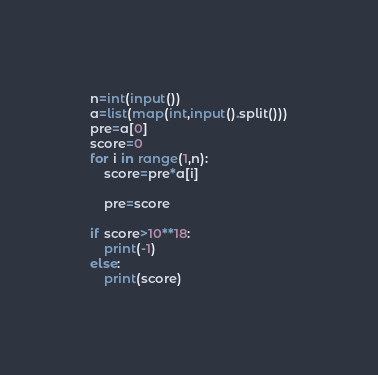<code> <loc_0><loc_0><loc_500><loc_500><_Python_>n=int(input())
a=list(map(int,input().split()))
pre=a[0]
score=0
for i in range(1,n):
    score=pre*a[i]
    
    pre=score
    
if score>10**18:
    print(-1)
else:
    print(score)</code> 